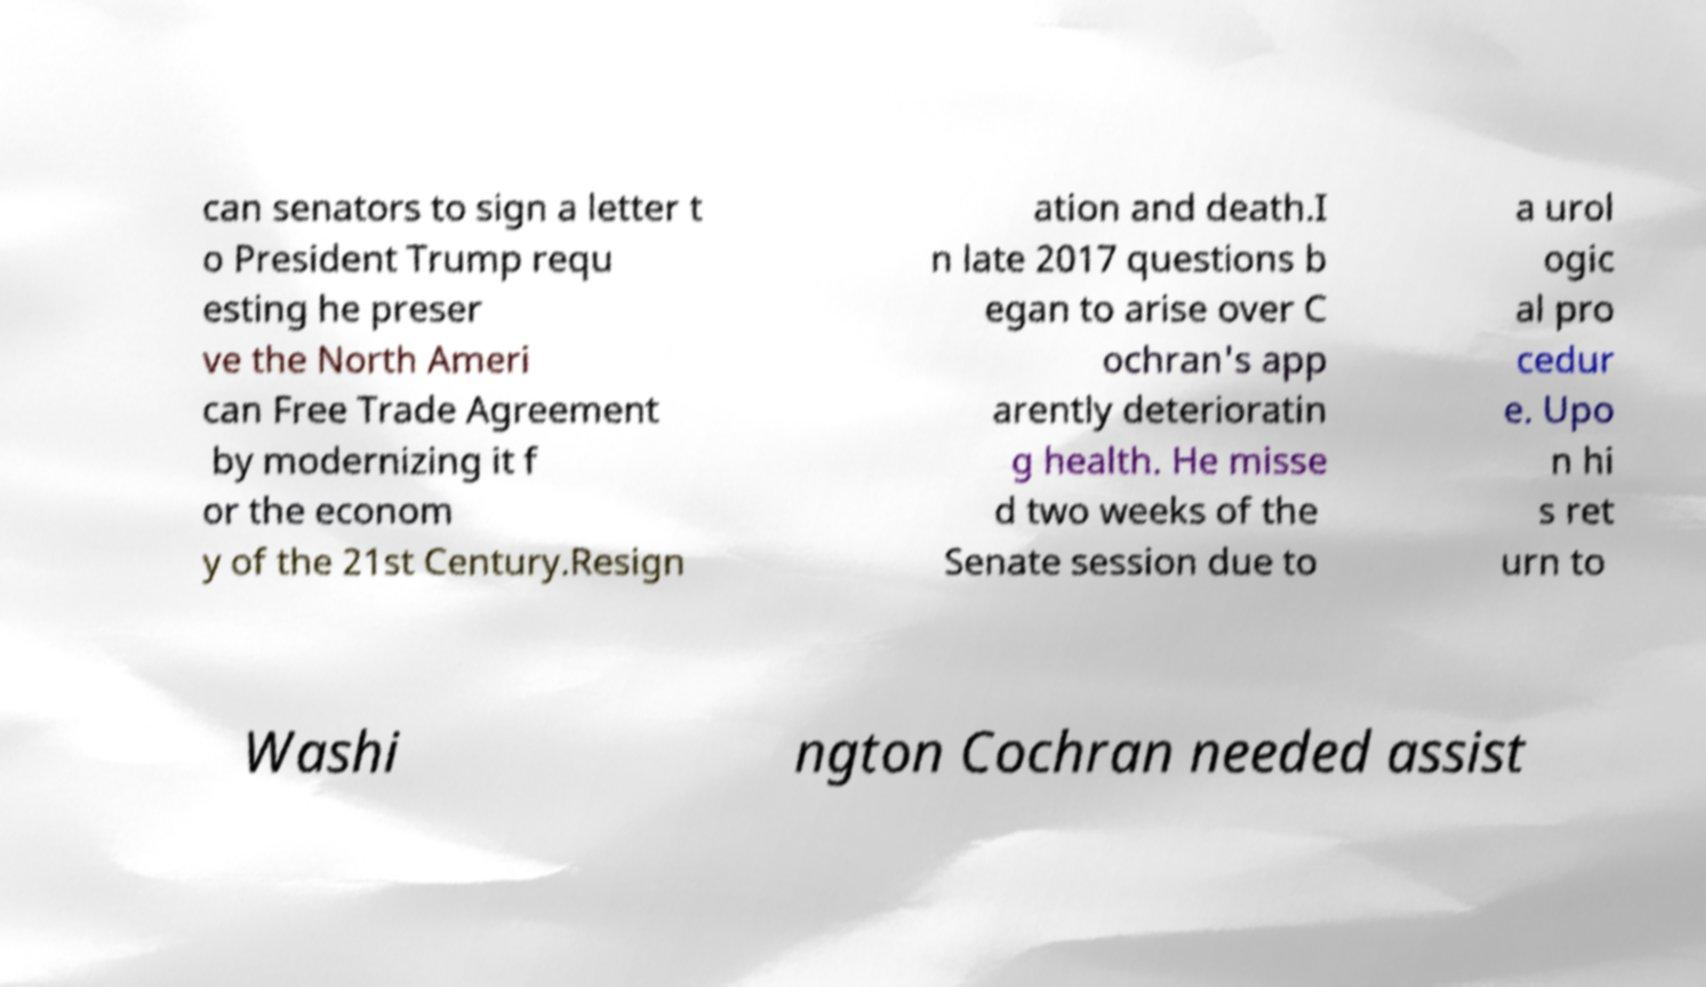Can you read and provide the text displayed in the image?This photo seems to have some interesting text. Can you extract and type it out for me? can senators to sign a letter t o President Trump requ esting he preser ve the North Ameri can Free Trade Agreement by modernizing it f or the econom y of the 21st Century.Resign ation and death.I n late 2017 questions b egan to arise over C ochran's app arently deterioratin g health. He misse d two weeks of the Senate session due to a urol ogic al pro cedur e. Upo n hi s ret urn to Washi ngton Cochran needed assist 